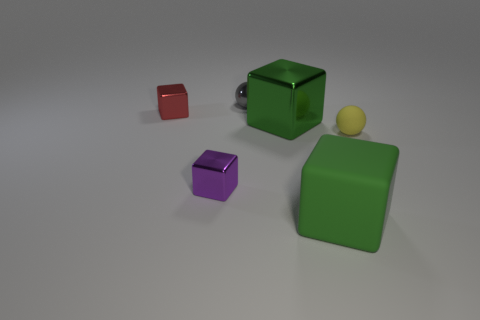Subtract all shiny cubes. How many cubes are left? 1 Subtract all cyan blocks. Subtract all brown cylinders. How many blocks are left? 4 Add 1 big shiny objects. How many objects exist? 7 Subtract all blocks. How many objects are left? 2 Subtract all large matte things. Subtract all small blocks. How many objects are left? 3 Add 3 green metal cubes. How many green metal cubes are left? 4 Add 1 big blocks. How many big blocks exist? 3 Subtract 0 red cylinders. How many objects are left? 6 